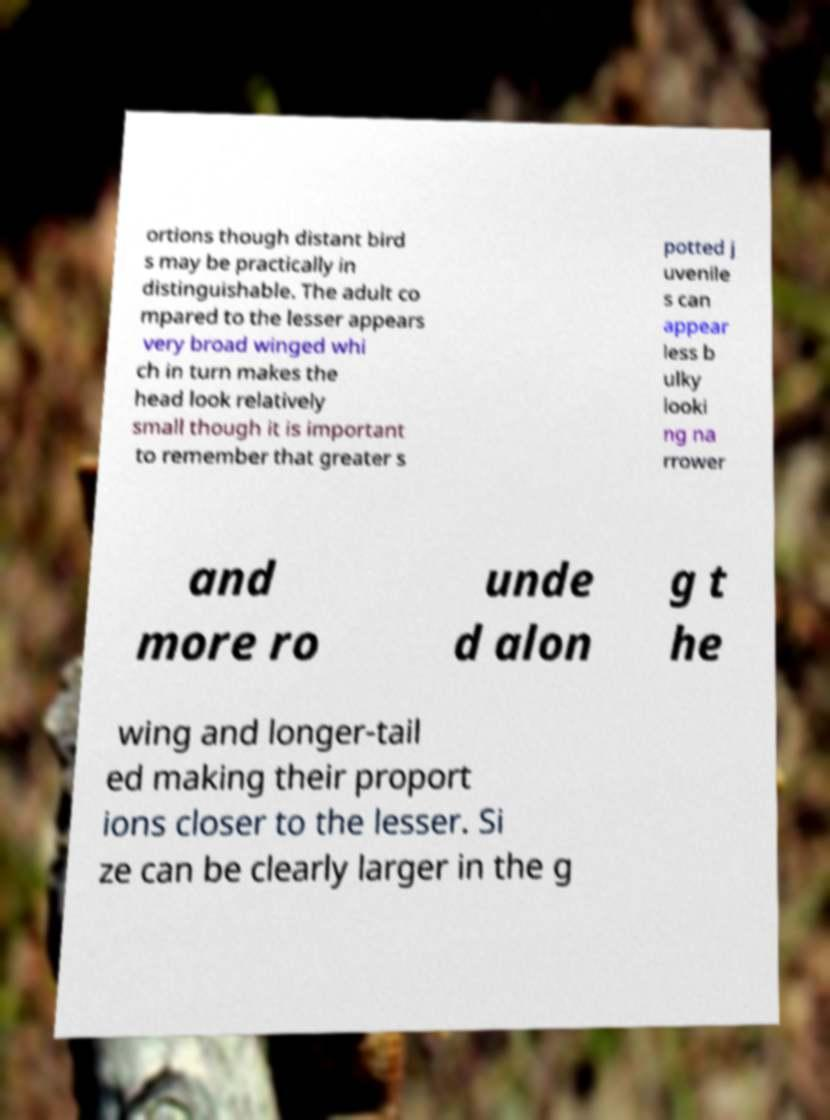Could you assist in decoding the text presented in this image and type it out clearly? ortions though distant bird s may be practically in distinguishable. The adult co mpared to the lesser appears very broad winged whi ch in turn makes the head look relatively small though it is important to remember that greater s potted j uvenile s can appear less b ulky looki ng na rrower and more ro unde d alon g t he wing and longer-tail ed making their proport ions closer to the lesser. Si ze can be clearly larger in the g 